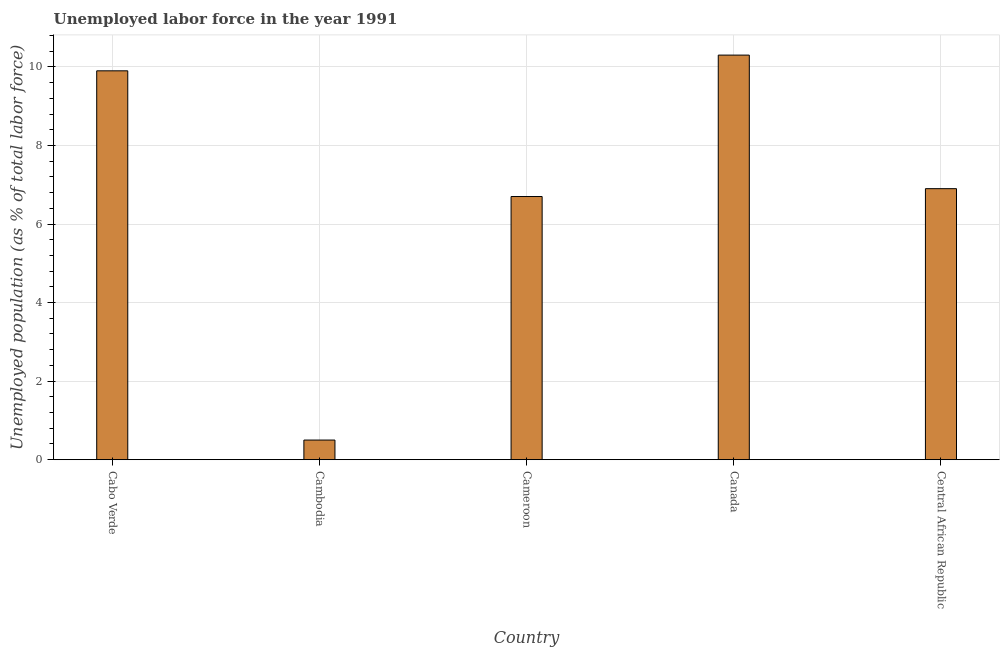Does the graph contain any zero values?
Your response must be concise. No. What is the title of the graph?
Your answer should be very brief. Unemployed labor force in the year 1991. What is the label or title of the Y-axis?
Your response must be concise. Unemployed population (as % of total labor force). What is the total unemployed population in Cameroon?
Your response must be concise. 6.7. Across all countries, what is the maximum total unemployed population?
Provide a short and direct response. 10.3. In which country was the total unemployed population maximum?
Your answer should be compact. Canada. In which country was the total unemployed population minimum?
Your response must be concise. Cambodia. What is the sum of the total unemployed population?
Your response must be concise. 34.3. What is the average total unemployed population per country?
Provide a short and direct response. 6.86. What is the median total unemployed population?
Offer a very short reply. 6.9. How many bars are there?
Your response must be concise. 5. What is the difference between two consecutive major ticks on the Y-axis?
Make the answer very short. 2. What is the Unemployed population (as % of total labor force) in Cabo Verde?
Keep it short and to the point. 9.9. What is the Unemployed population (as % of total labor force) of Cameroon?
Provide a short and direct response. 6.7. What is the Unemployed population (as % of total labor force) of Canada?
Your response must be concise. 10.3. What is the Unemployed population (as % of total labor force) of Central African Republic?
Your response must be concise. 6.9. What is the difference between the Unemployed population (as % of total labor force) in Cabo Verde and Cambodia?
Keep it short and to the point. 9.4. What is the difference between the Unemployed population (as % of total labor force) in Cabo Verde and Cameroon?
Keep it short and to the point. 3.2. What is the difference between the Unemployed population (as % of total labor force) in Cabo Verde and Central African Republic?
Give a very brief answer. 3. What is the difference between the Unemployed population (as % of total labor force) in Cambodia and Cameroon?
Your answer should be compact. -6.2. What is the difference between the Unemployed population (as % of total labor force) in Cambodia and Canada?
Offer a very short reply. -9.8. What is the difference between the Unemployed population (as % of total labor force) in Cambodia and Central African Republic?
Offer a terse response. -6.4. What is the difference between the Unemployed population (as % of total labor force) in Cameroon and Canada?
Give a very brief answer. -3.6. What is the difference between the Unemployed population (as % of total labor force) in Cameroon and Central African Republic?
Ensure brevity in your answer.  -0.2. What is the ratio of the Unemployed population (as % of total labor force) in Cabo Verde to that in Cambodia?
Your answer should be very brief. 19.8. What is the ratio of the Unemployed population (as % of total labor force) in Cabo Verde to that in Cameroon?
Your response must be concise. 1.48. What is the ratio of the Unemployed population (as % of total labor force) in Cabo Verde to that in Central African Republic?
Offer a very short reply. 1.44. What is the ratio of the Unemployed population (as % of total labor force) in Cambodia to that in Cameroon?
Provide a short and direct response. 0.07. What is the ratio of the Unemployed population (as % of total labor force) in Cambodia to that in Canada?
Keep it short and to the point. 0.05. What is the ratio of the Unemployed population (as % of total labor force) in Cambodia to that in Central African Republic?
Keep it short and to the point. 0.07. What is the ratio of the Unemployed population (as % of total labor force) in Cameroon to that in Canada?
Provide a succinct answer. 0.65. What is the ratio of the Unemployed population (as % of total labor force) in Cameroon to that in Central African Republic?
Give a very brief answer. 0.97. What is the ratio of the Unemployed population (as % of total labor force) in Canada to that in Central African Republic?
Offer a very short reply. 1.49. 